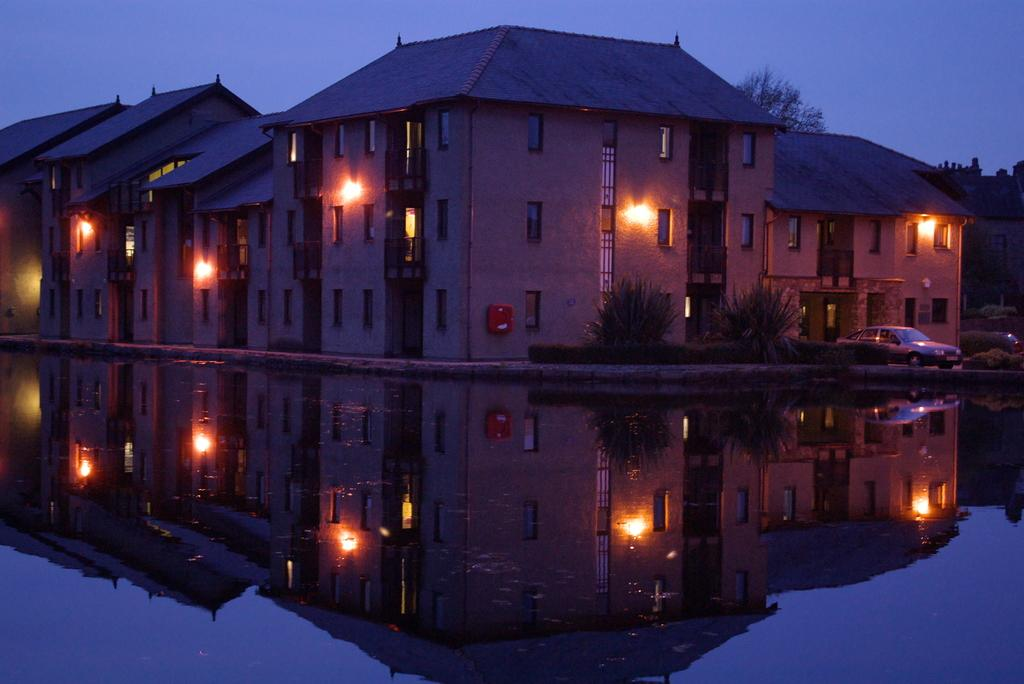What type of structures can be seen in the image? There are houses in the image. What feature do the houses have? The houses have windows. What natural element is visible in the image? There is water visible in the image. What type of vegetation is present in the image? There is a tree in the image. What part of the natural environment is visible in the image? The sky is visible in the image. What type of range can be seen in the image? There is no range present in the image. What shape is the square in the image? There is no square present in the image. 